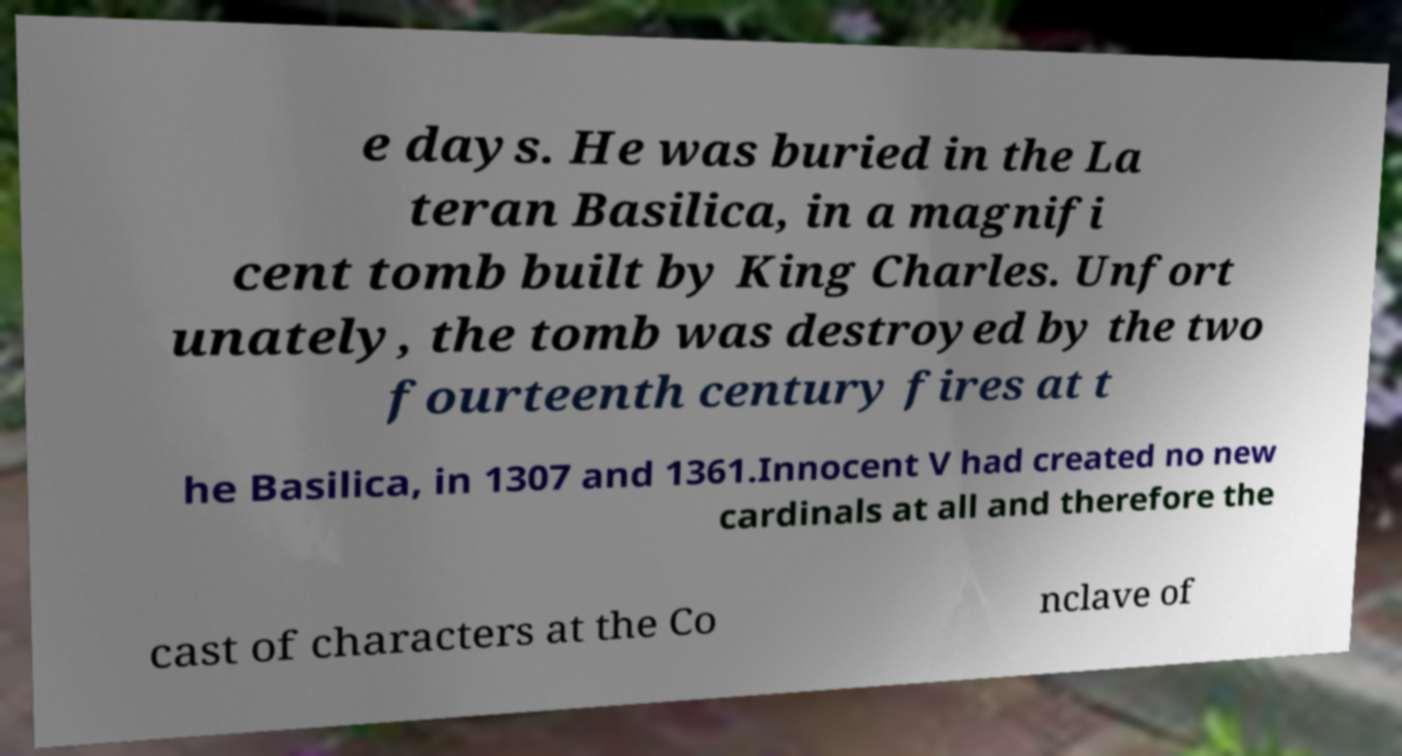Please identify and transcribe the text found in this image. e days. He was buried in the La teran Basilica, in a magnifi cent tomb built by King Charles. Unfort unately, the tomb was destroyed by the two fourteenth century fires at t he Basilica, in 1307 and 1361.Innocent V had created no new cardinals at all and therefore the cast of characters at the Co nclave of 